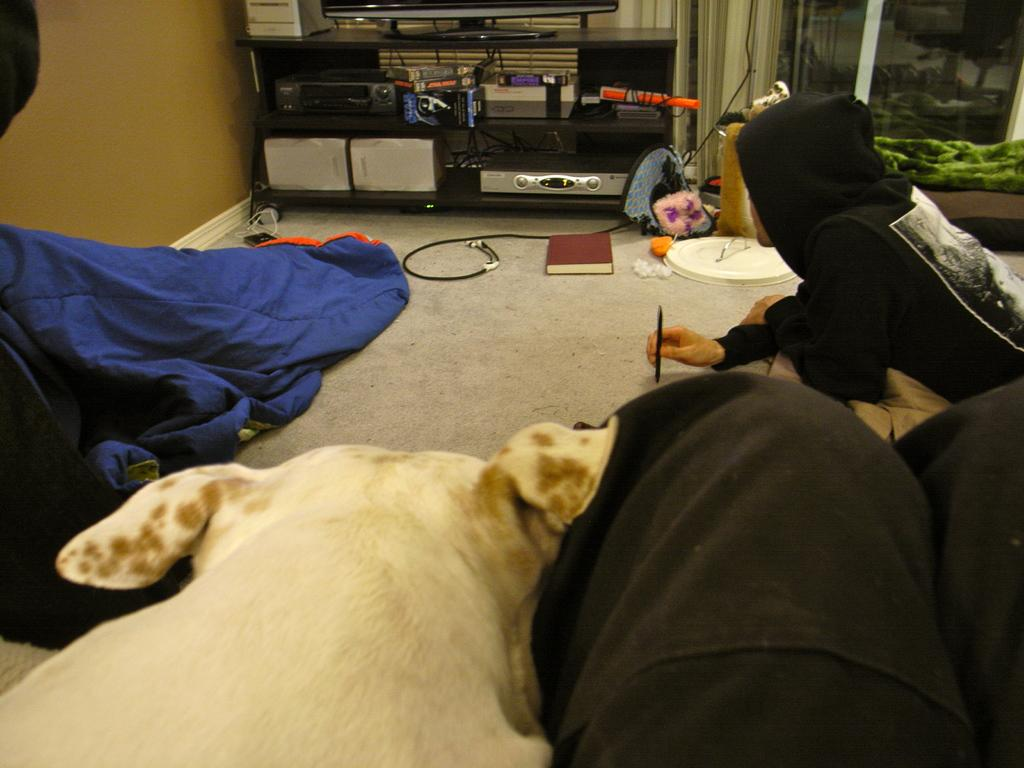How many people are in the image? There are people in the image, but the exact number is not specified. What type of animal is in the image? There is a dog in the image. What is on the table in the image? There is a television on a table in the image. What is on the floor in the image? There is a book and items on the floor in the image. What is covering part of the floor in the image? There is a blanket on the floor in the image. What type of lipstick is the ghost wearing in the image? There is no ghost present in the image, so it is not possible to determine what type of lipstick the ghost might be wearing. 